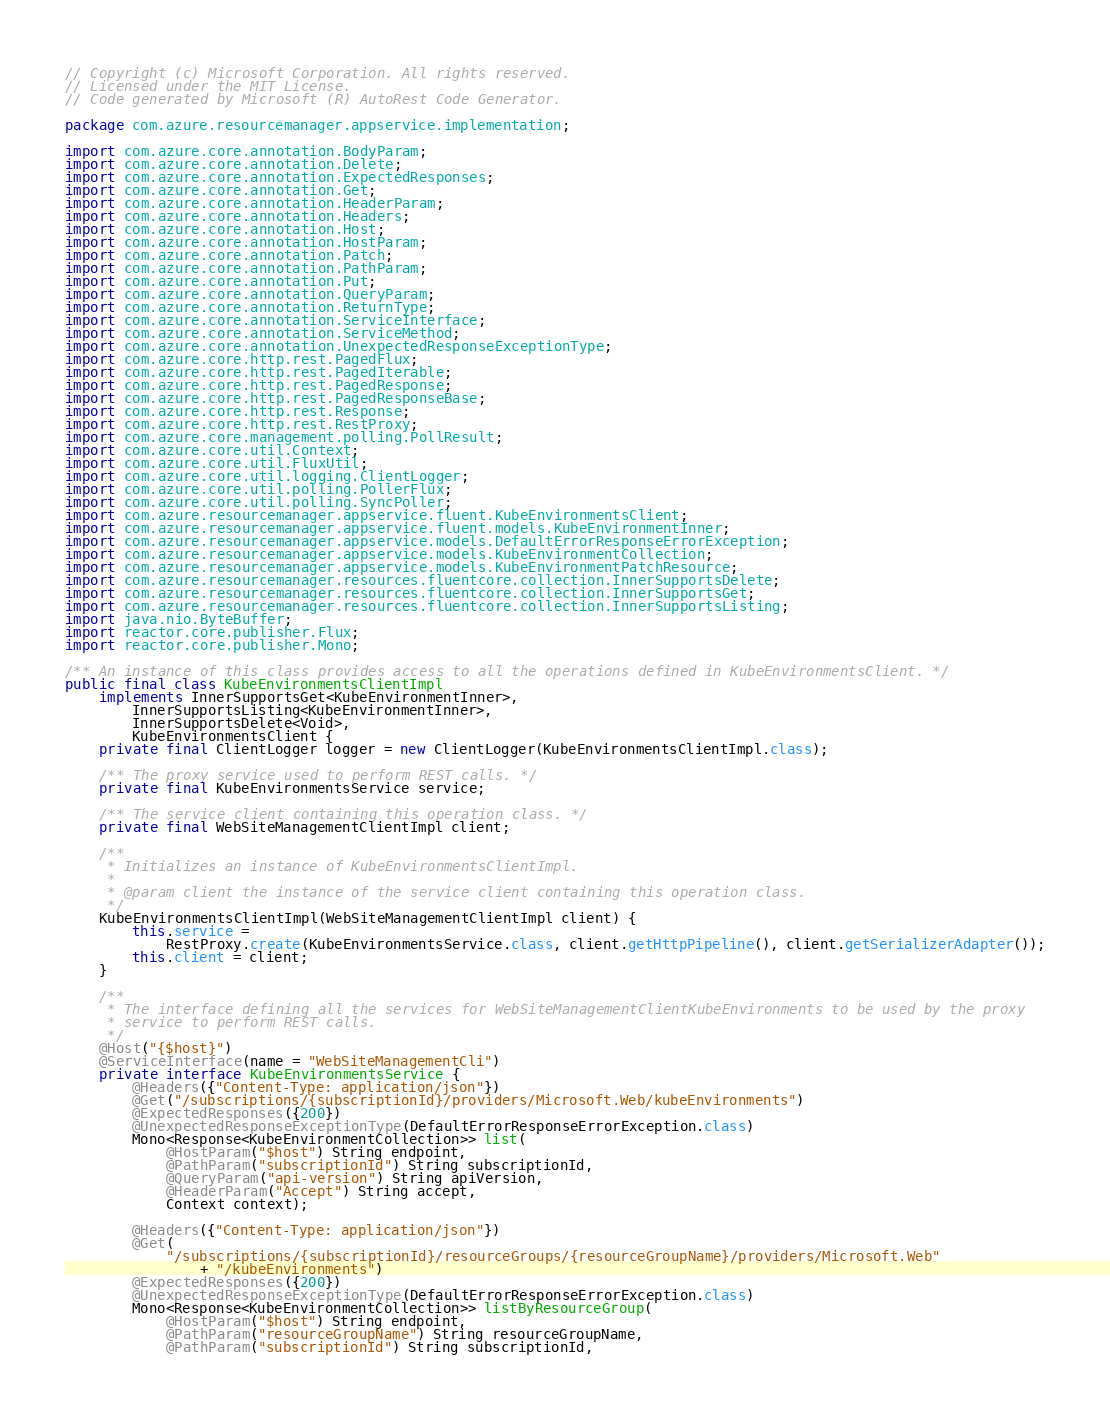Convert code to text. <code><loc_0><loc_0><loc_500><loc_500><_Java_>// Copyright (c) Microsoft Corporation. All rights reserved.
// Licensed under the MIT License.
// Code generated by Microsoft (R) AutoRest Code Generator.

package com.azure.resourcemanager.appservice.implementation;

import com.azure.core.annotation.BodyParam;
import com.azure.core.annotation.Delete;
import com.azure.core.annotation.ExpectedResponses;
import com.azure.core.annotation.Get;
import com.azure.core.annotation.HeaderParam;
import com.azure.core.annotation.Headers;
import com.azure.core.annotation.Host;
import com.azure.core.annotation.HostParam;
import com.azure.core.annotation.Patch;
import com.azure.core.annotation.PathParam;
import com.azure.core.annotation.Put;
import com.azure.core.annotation.QueryParam;
import com.azure.core.annotation.ReturnType;
import com.azure.core.annotation.ServiceInterface;
import com.azure.core.annotation.ServiceMethod;
import com.azure.core.annotation.UnexpectedResponseExceptionType;
import com.azure.core.http.rest.PagedFlux;
import com.azure.core.http.rest.PagedIterable;
import com.azure.core.http.rest.PagedResponse;
import com.azure.core.http.rest.PagedResponseBase;
import com.azure.core.http.rest.Response;
import com.azure.core.http.rest.RestProxy;
import com.azure.core.management.polling.PollResult;
import com.azure.core.util.Context;
import com.azure.core.util.FluxUtil;
import com.azure.core.util.logging.ClientLogger;
import com.azure.core.util.polling.PollerFlux;
import com.azure.core.util.polling.SyncPoller;
import com.azure.resourcemanager.appservice.fluent.KubeEnvironmentsClient;
import com.azure.resourcemanager.appservice.fluent.models.KubeEnvironmentInner;
import com.azure.resourcemanager.appservice.models.DefaultErrorResponseErrorException;
import com.azure.resourcemanager.appservice.models.KubeEnvironmentCollection;
import com.azure.resourcemanager.appservice.models.KubeEnvironmentPatchResource;
import com.azure.resourcemanager.resources.fluentcore.collection.InnerSupportsDelete;
import com.azure.resourcemanager.resources.fluentcore.collection.InnerSupportsGet;
import com.azure.resourcemanager.resources.fluentcore.collection.InnerSupportsListing;
import java.nio.ByteBuffer;
import reactor.core.publisher.Flux;
import reactor.core.publisher.Mono;

/** An instance of this class provides access to all the operations defined in KubeEnvironmentsClient. */
public final class KubeEnvironmentsClientImpl
    implements InnerSupportsGet<KubeEnvironmentInner>,
        InnerSupportsListing<KubeEnvironmentInner>,
        InnerSupportsDelete<Void>,
        KubeEnvironmentsClient {
    private final ClientLogger logger = new ClientLogger(KubeEnvironmentsClientImpl.class);

    /** The proxy service used to perform REST calls. */
    private final KubeEnvironmentsService service;

    /** The service client containing this operation class. */
    private final WebSiteManagementClientImpl client;

    /**
     * Initializes an instance of KubeEnvironmentsClientImpl.
     *
     * @param client the instance of the service client containing this operation class.
     */
    KubeEnvironmentsClientImpl(WebSiteManagementClientImpl client) {
        this.service =
            RestProxy.create(KubeEnvironmentsService.class, client.getHttpPipeline(), client.getSerializerAdapter());
        this.client = client;
    }

    /**
     * The interface defining all the services for WebSiteManagementClientKubeEnvironments to be used by the proxy
     * service to perform REST calls.
     */
    @Host("{$host}")
    @ServiceInterface(name = "WebSiteManagementCli")
    private interface KubeEnvironmentsService {
        @Headers({"Content-Type: application/json"})
        @Get("/subscriptions/{subscriptionId}/providers/Microsoft.Web/kubeEnvironments")
        @ExpectedResponses({200})
        @UnexpectedResponseExceptionType(DefaultErrorResponseErrorException.class)
        Mono<Response<KubeEnvironmentCollection>> list(
            @HostParam("$host") String endpoint,
            @PathParam("subscriptionId") String subscriptionId,
            @QueryParam("api-version") String apiVersion,
            @HeaderParam("Accept") String accept,
            Context context);

        @Headers({"Content-Type: application/json"})
        @Get(
            "/subscriptions/{subscriptionId}/resourceGroups/{resourceGroupName}/providers/Microsoft.Web"
                + "/kubeEnvironments")
        @ExpectedResponses({200})
        @UnexpectedResponseExceptionType(DefaultErrorResponseErrorException.class)
        Mono<Response<KubeEnvironmentCollection>> listByResourceGroup(
            @HostParam("$host") String endpoint,
            @PathParam("resourceGroupName") String resourceGroupName,
            @PathParam("subscriptionId") String subscriptionId,</code> 